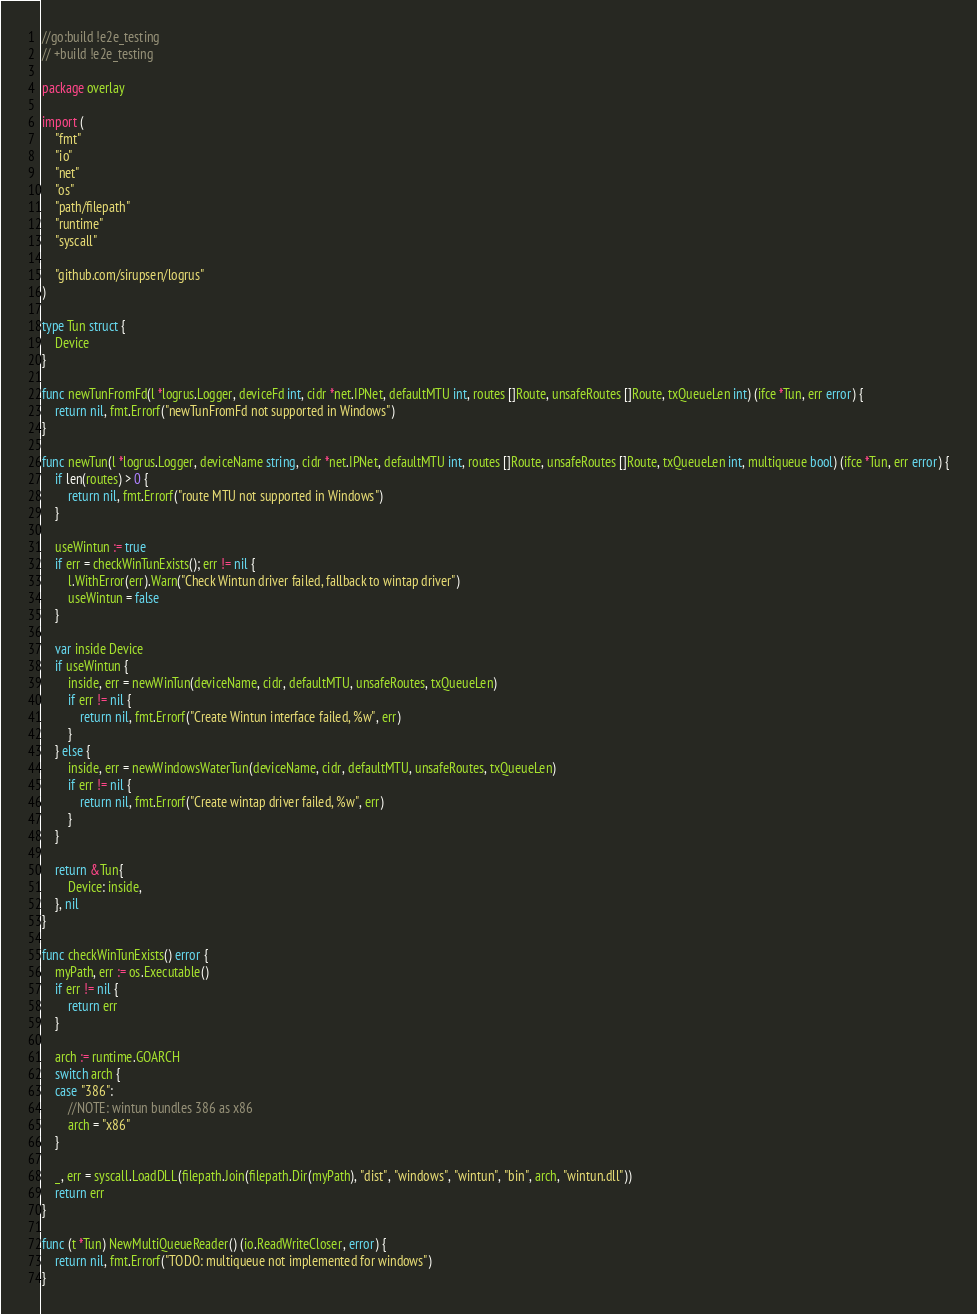Convert code to text. <code><loc_0><loc_0><loc_500><loc_500><_Go_>//go:build !e2e_testing
// +build !e2e_testing

package overlay

import (
	"fmt"
	"io"
	"net"
	"os"
	"path/filepath"
	"runtime"
	"syscall"

	"github.com/sirupsen/logrus"
)

type Tun struct {
	Device
}

func newTunFromFd(l *logrus.Logger, deviceFd int, cidr *net.IPNet, defaultMTU int, routes []Route, unsafeRoutes []Route, txQueueLen int) (ifce *Tun, err error) {
	return nil, fmt.Errorf("newTunFromFd not supported in Windows")
}

func newTun(l *logrus.Logger, deviceName string, cidr *net.IPNet, defaultMTU int, routes []Route, unsafeRoutes []Route, txQueueLen int, multiqueue bool) (ifce *Tun, err error) {
	if len(routes) > 0 {
		return nil, fmt.Errorf("route MTU not supported in Windows")
	}

	useWintun := true
	if err = checkWinTunExists(); err != nil {
		l.WithError(err).Warn("Check Wintun driver failed, fallback to wintap driver")
		useWintun = false
	}

	var inside Device
	if useWintun {
		inside, err = newWinTun(deviceName, cidr, defaultMTU, unsafeRoutes, txQueueLen)
		if err != nil {
			return nil, fmt.Errorf("Create Wintun interface failed, %w", err)
		}
	} else {
		inside, err = newWindowsWaterTun(deviceName, cidr, defaultMTU, unsafeRoutes, txQueueLen)
		if err != nil {
			return nil, fmt.Errorf("Create wintap driver failed, %w", err)
		}
	}

	return &Tun{
		Device: inside,
	}, nil
}

func checkWinTunExists() error {
	myPath, err := os.Executable()
	if err != nil {
		return err
	}

	arch := runtime.GOARCH
	switch arch {
	case "386":
		//NOTE: wintun bundles 386 as x86
		arch = "x86"
	}

	_, err = syscall.LoadDLL(filepath.Join(filepath.Dir(myPath), "dist", "windows", "wintun", "bin", arch, "wintun.dll"))
	return err
}

func (t *Tun) NewMultiQueueReader() (io.ReadWriteCloser, error) {
	return nil, fmt.Errorf("TODO: multiqueue not implemented for windows")
}
</code> 